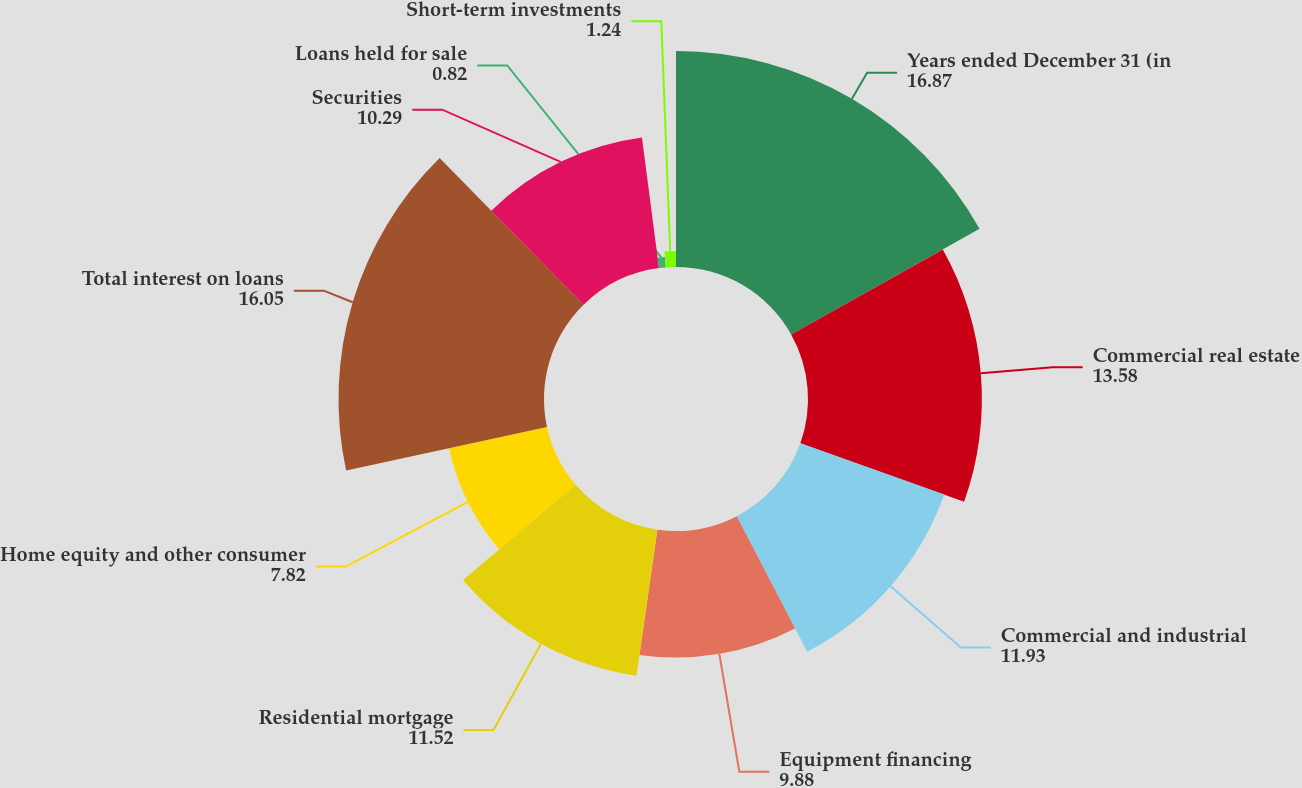Convert chart to OTSL. <chart><loc_0><loc_0><loc_500><loc_500><pie_chart><fcel>Years ended December 31 (in<fcel>Commercial real estate<fcel>Commercial and industrial<fcel>Equipment financing<fcel>Residential mortgage<fcel>Home equity and other consumer<fcel>Total interest on loans<fcel>Securities<fcel>Loans held for sale<fcel>Short-term investments<nl><fcel>16.87%<fcel>13.58%<fcel>11.93%<fcel>9.88%<fcel>11.52%<fcel>7.82%<fcel>16.05%<fcel>10.29%<fcel>0.82%<fcel>1.24%<nl></chart> 